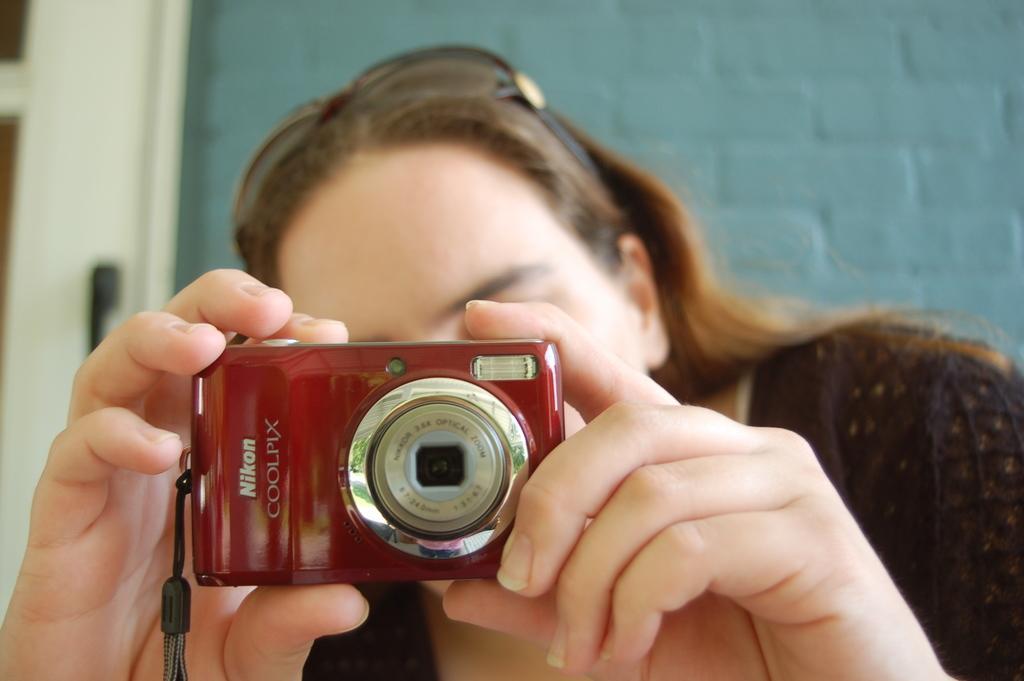In one or two sentences, can you explain what this image depicts? In this image we can see a person holding camera in the hands and in the background there are walls. 